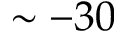Convert formula to latex. <formula><loc_0><loc_0><loc_500><loc_500>\sim - 3 0</formula> 